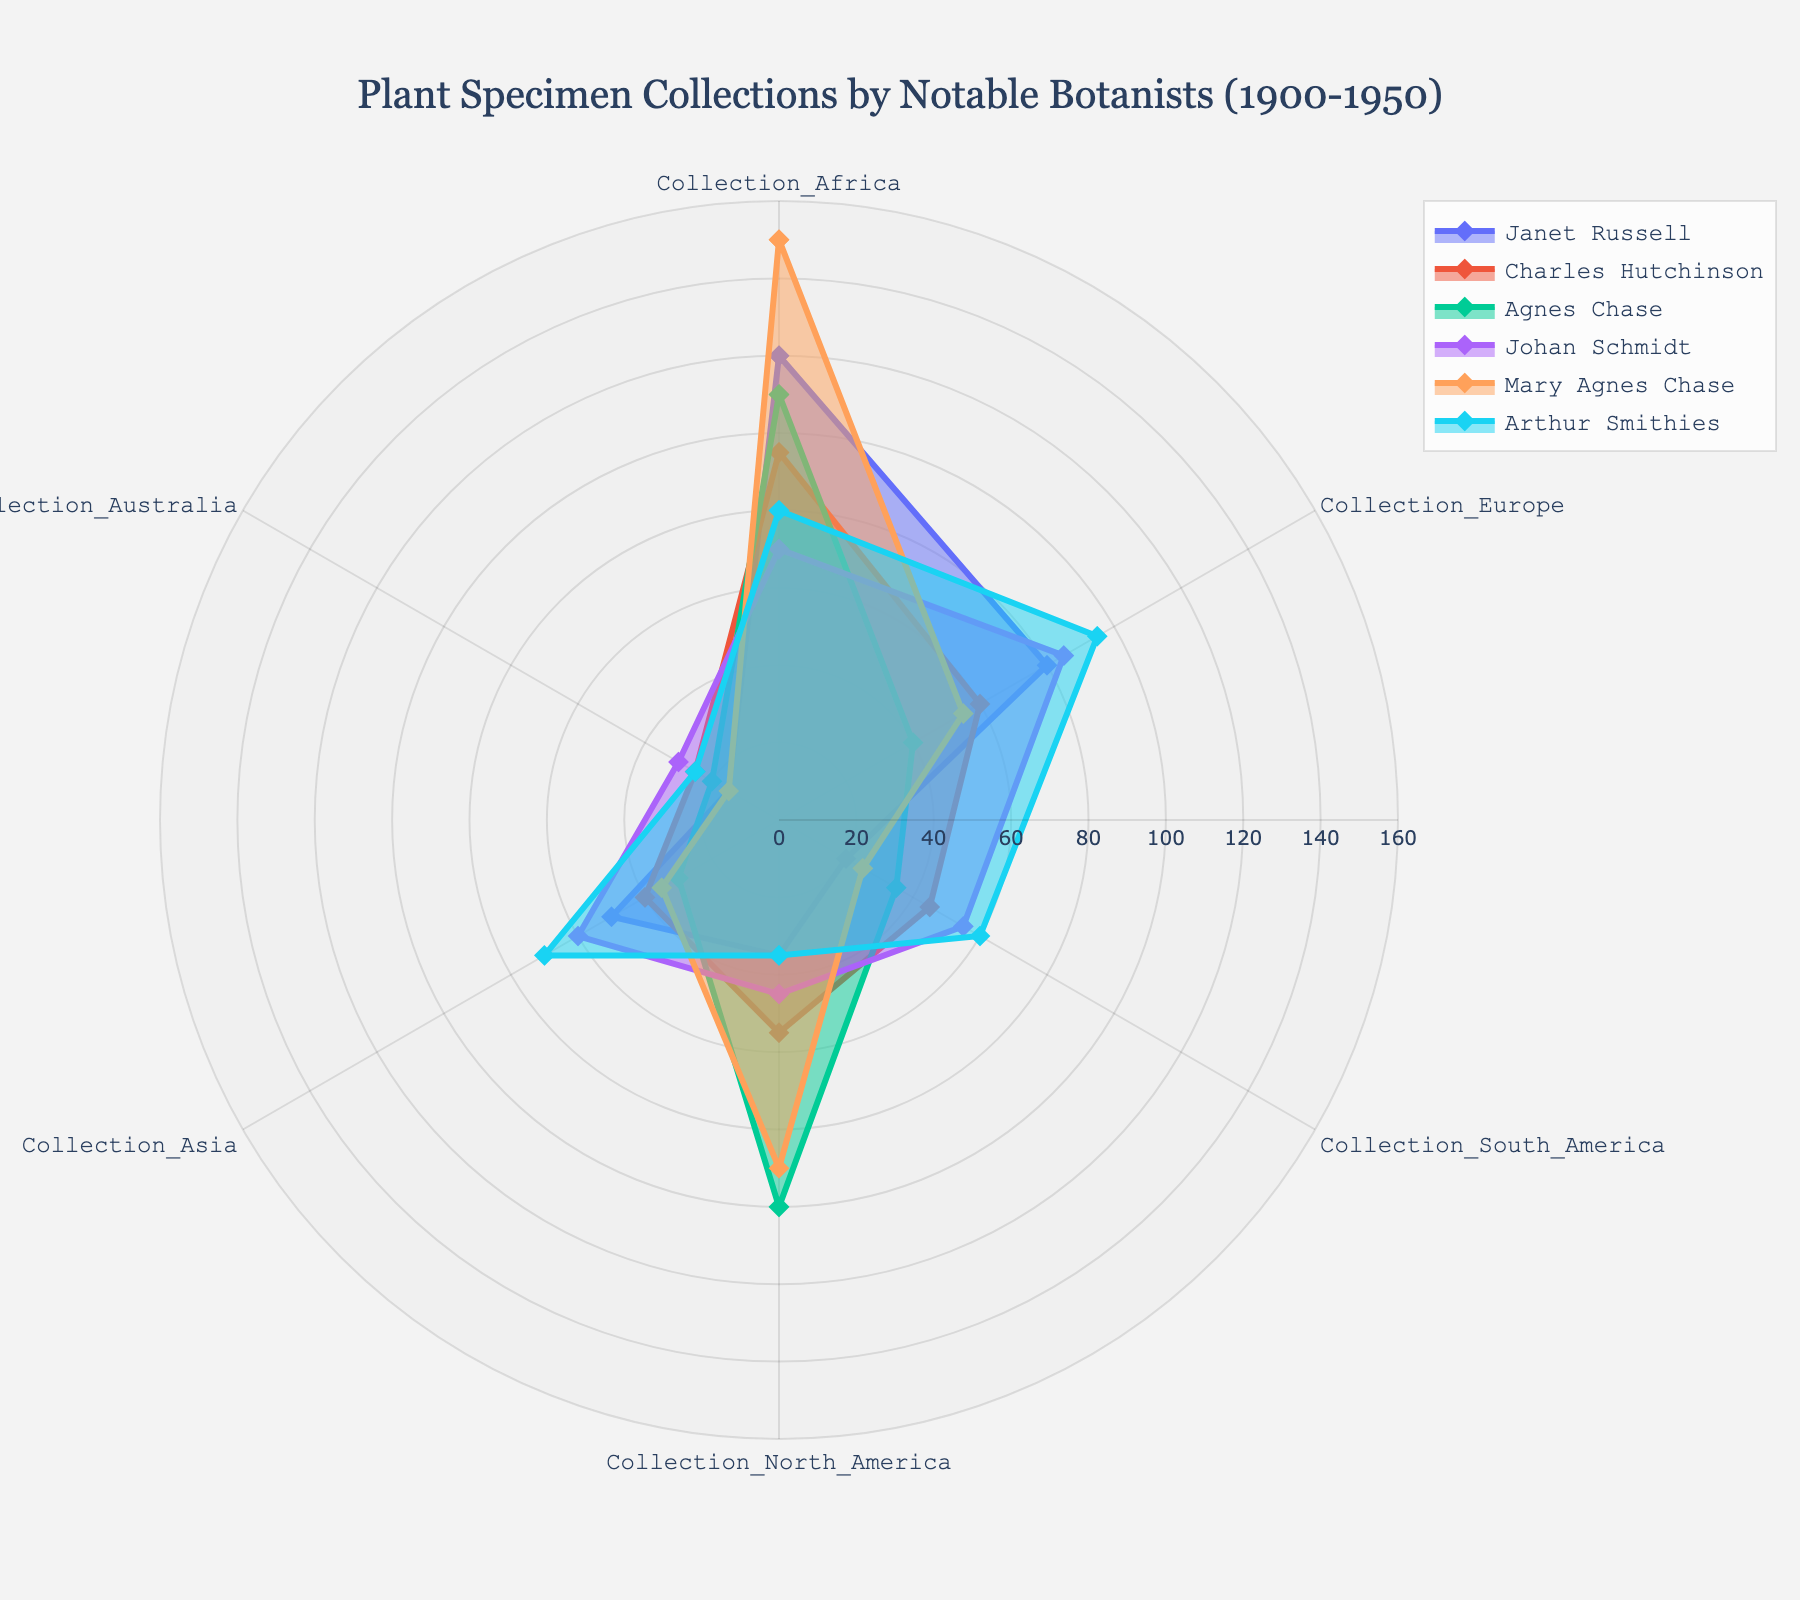What is the title of the radar chart? The title of the radar chart is displayed prominently at the top of the figure. It reads "Plant Specimen Collections by Notable Botanists (1900-1950)".
Answer: Plant Specimen Collections by Notable Botanists (1900-1950) Which botanist collected the most specimens in Africa? To determine which botanist collected the most specimens in Africa, refer to the "Collection_Africa" axis on the radar chart. The botanist with the outermost data point on this axis represents the highest value, in this case, Mary Agnes Chase with 150 specimens.
Answer: Mary Agnes Chase Who has the smallest total number of collections across all regions? To find this, sum the values for each botanist in all regions shown in the chart. Arthur Smithies: 80+95+60+35+70+25 = 365, Johan Schmidt: 70+85+55+45+60+30 = 345, Agnes Chase: 110+40+35+100+30+20 = 335, Charles Hutchinson: 95+60+45+55+40+25 = 320, Janet Russell: 120+80+20+35+50+15 = 320, Mary Agnes Chase: 150+55+25+90+35+15 = 370. Charles Hutchinson and Janet Russell both have the smallest total, 320.
Answer: Charles Hutchinson and Janet Russell For which region is Arthur Smithies' specimen collection highest? Refer to the values for Arthur Smithies on each region axis of the radar chart and identify the highest value. It is for "Collection_Europe" with 95 specimens.
Answer: Collection_Europe Compare the number of specimens collected in North America by Agnes Chase and Mary Agnes Chase. Who collected more and by how much? Check the "Collection_North_America" axis for Agnes Chase (100 specimens) and Mary Agnes Chase (90 specimens). Agnes Chase collected 10 more specimens than Mary Agnes Chase.
Answer: Agnes Chase by 10 specimens Which botanist has the broadest range in the number of specimens collected across different regions? The range is determined by the difference between the highest and lowest values for each botanist. Calculate for each: Janet Russell: 120-15, Charles Hutchinson: 95-25, Agnes Chase: 110-20, Johan Schmidt: 85-30, Mary Agnes Chase: 150-15, Arthur Smithies: 95-25. Mary Agnes Chase has the broadest range (150-15 = 135).
Answer: Mary Agnes Chase Who collected more specimens in Europe: Johan Schmidt or Janet Russell? Compare the values on the "Collection_Europe" axis. Johan Schmidt collected 85 specimens, and Janet Russell collected 80 specimens. Johan Schmidt collected more.
Answer: Johan Schmidt What is the average number of specimens collected by all botanists in South America? To find the average, sum the "Collection_South_America" values for all botanists and divide by the number of botanists. (20+45+35+55+25+60)/6 = 240/6 = 40.
Answer: 40 Which two botanists have the most similar collection patterns across all regions? Patterns are most similar when their radar chart shapes closely match. By inspection, Janet Russell and Charles Hutchinson produce notably similar collection patterns.
Answer: Janet Russell and Charles Hutchinson 